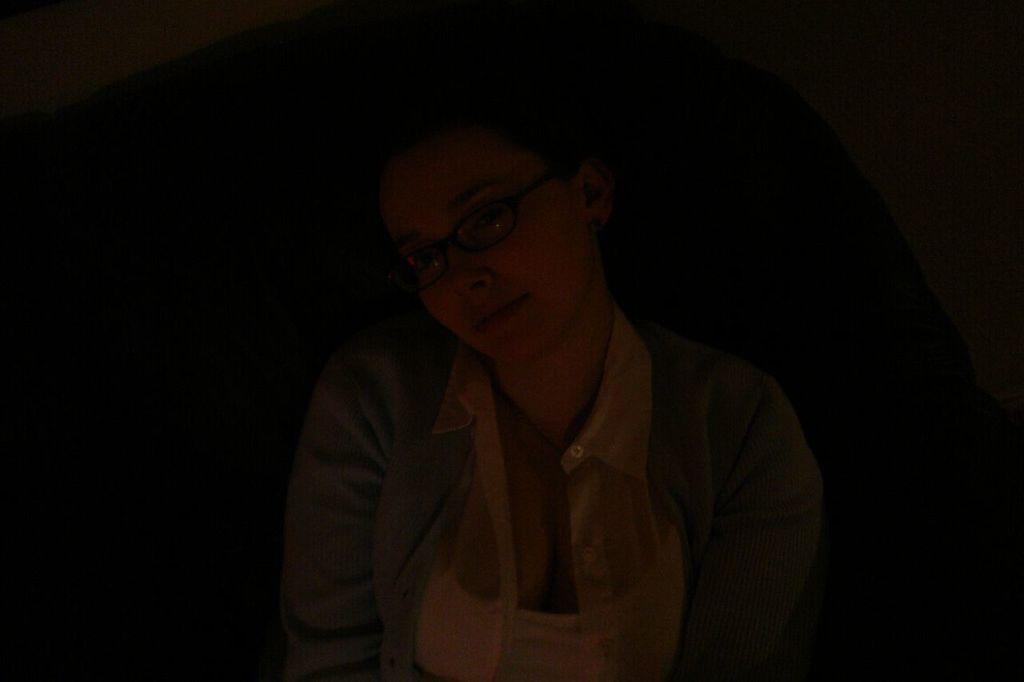What is the main subject of the image? There is a person in the image. Can you describe the lighting in the image? The image is dark. What type of organization is depicted in the image? There is no organization present in the image; it features a person in a dark setting. How much profit does the earth generate in the image? There is no reference to profit or the earth in the image; it only shows a person in a dark setting. 